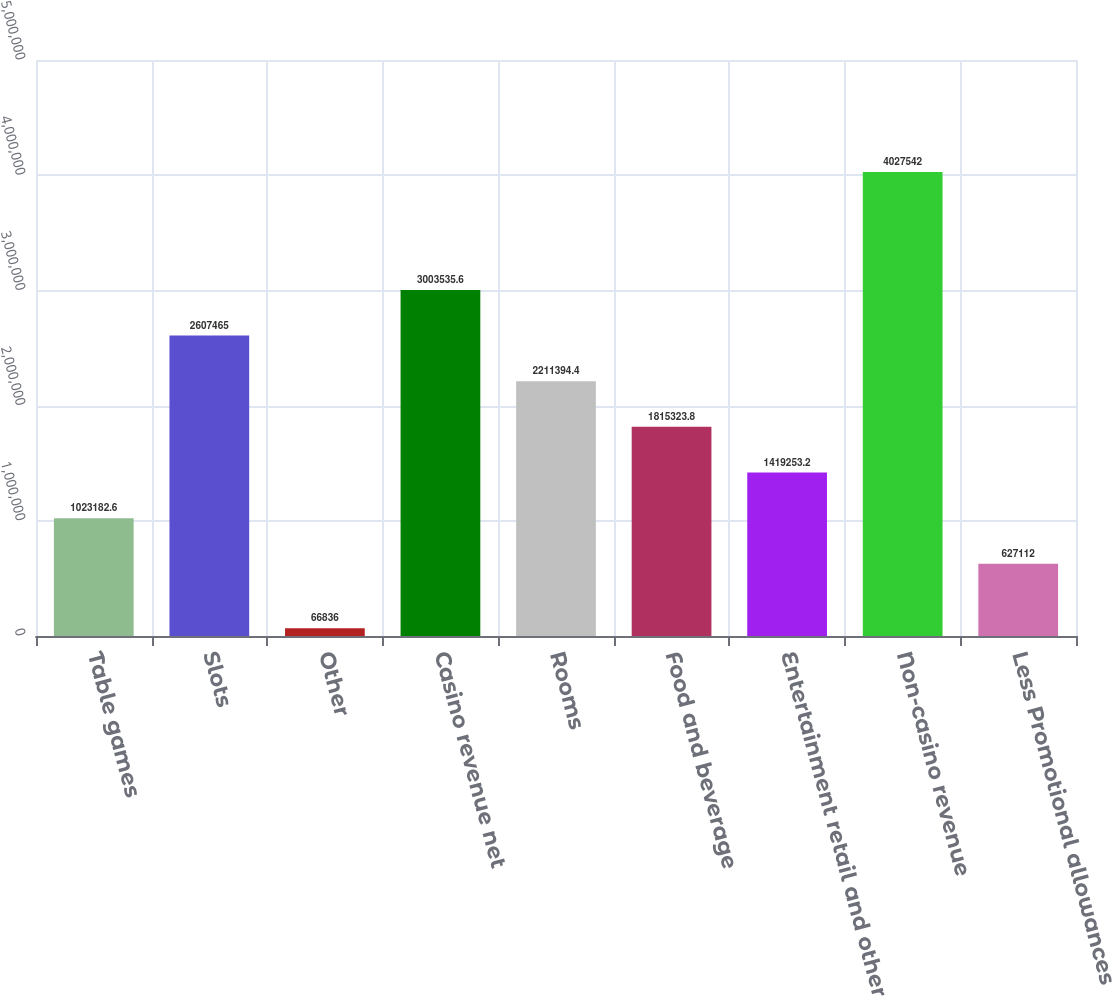<chart> <loc_0><loc_0><loc_500><loc_500><bar_chart><fcel>Table games<fcel>Slots<fcel>Other<fcel>Casino revenue net<fcel>Rooms<fcel>Food and beverage<fcel>Entertainment retail and other<fcel>Non-casino revenue<fcel>Less Promotional allowances<nl><fcel>1.02318e+06<fcel>2.60746e+06<fcel>66836<fcel>3.00354e+06<fcel>2.21139e+06<fcel>1.81532e+06<fcel>1.41925e+06<fcel>4.02754e+06<fcel>627112<nl></chart> 